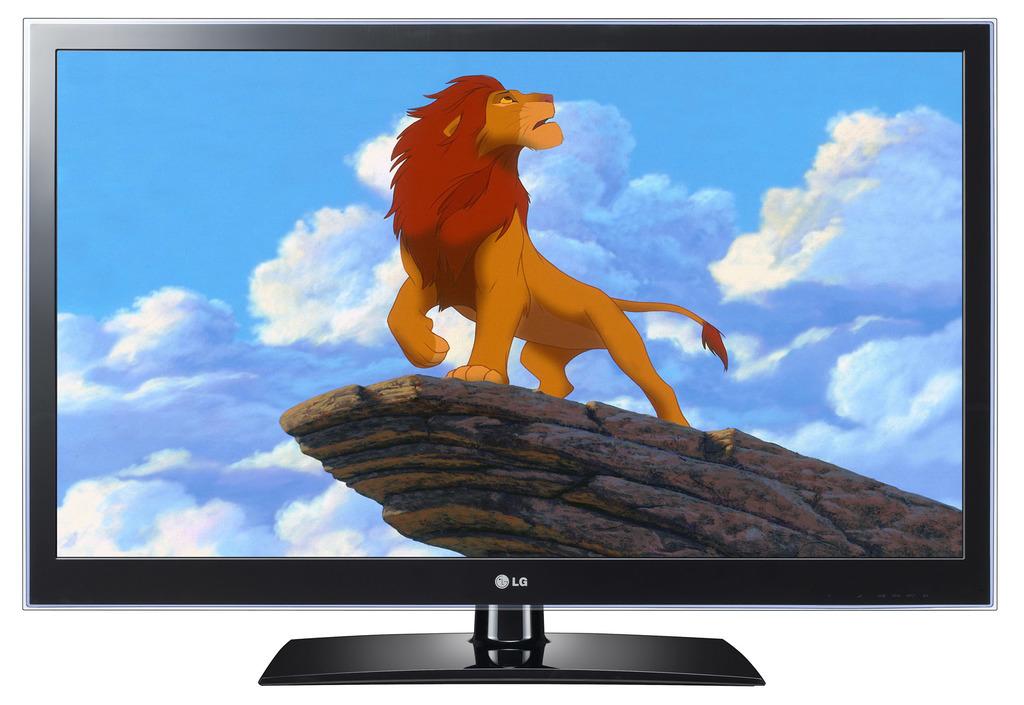What brand is this tv?
Ensure brevity in your answer.  Lg. 